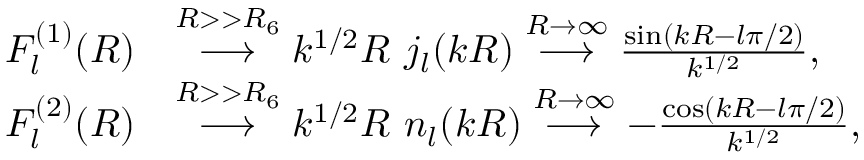Convert formula to latex. <formula><loc_0><loc_0><loc_500><loc_500>\begin{array} { r l } { F _ { l } ^ { ( 1 ) } ( R ) } & { \stackrel { R > > R _ { 6 } } { \longrightarrow } k ^ { 1 / 2 } R \, j _ { l } ( k R ) \stackrel { R \to \infty } { \longrightarrow } \frac { \sin ( k R - l \pi / 2 ) } { k ^ { 1 / 2 } } , } \\ { F _ { l } ^ { ( 2 ) } ( R ) } & { \stackrel { R > > R _ { 6 } } { \longrightarrow } k ^ { 1 / 2 } R \, n _ { l } ( k R ) \stackrel { R \to \infty } { \longrightarrow } - \frac { \cos ( k R - l \pi / 2 ) } { k ^ { 1 / 2 } } , } \end{array}</formula> 